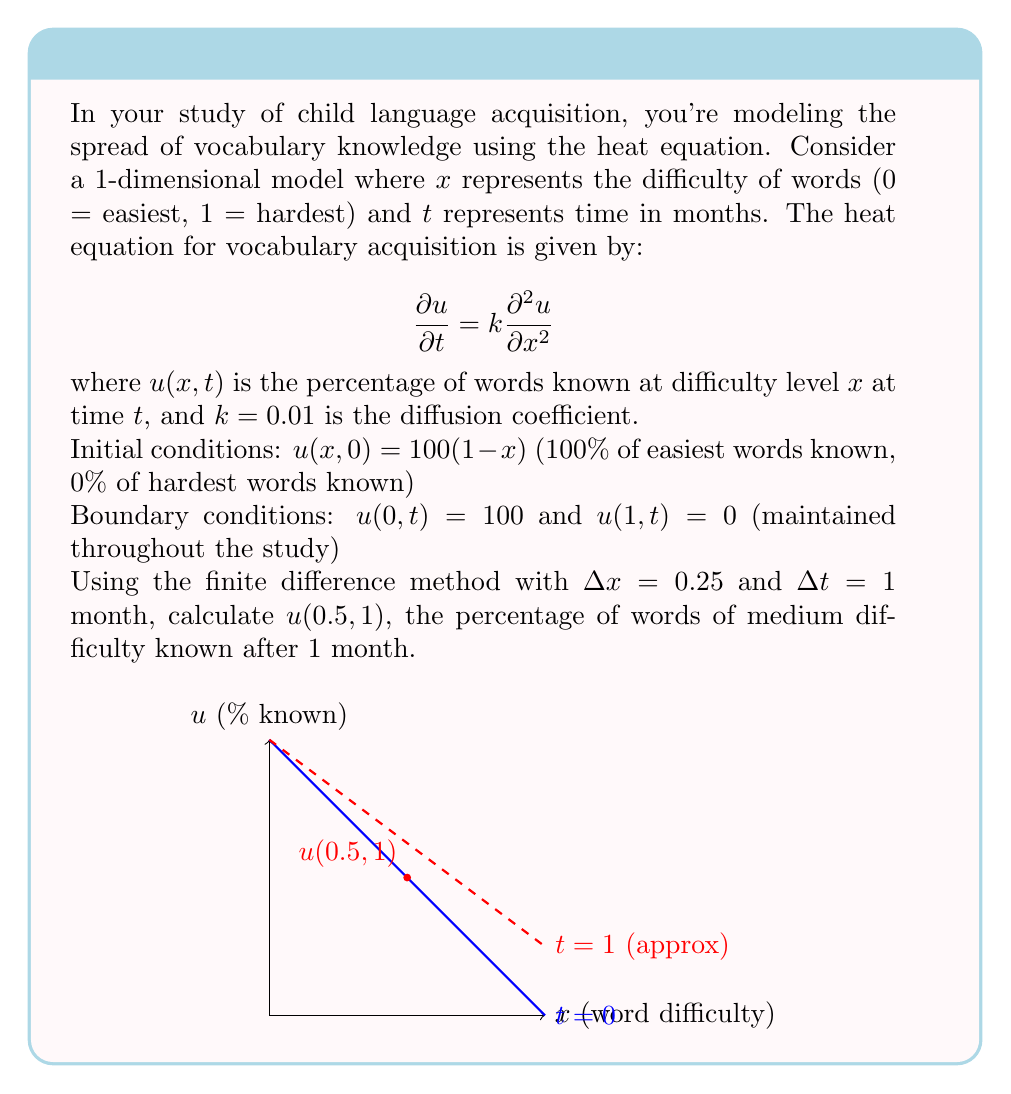Solve this math problem. Let's solve this step-by-step using the finite difference method:

1) The finite difference approximation for the heat equation is:

   $$\frac{u_i^{j+1} - u_i^j}{\Delta t} = k\frac{u_{i+1}^j - 2u_i^j + u_{i-1}^j}{(\Delta x)^2}$$

2) Rearranging to solve for $u_i^{j+1}$:

   $$u_i^{j+1} = u_i^j + \frac{k\Delta t}{(\Delta x)^2}(u_{i+1}^j - 2u_i^j + u_{i-1}^j)$$

3) Given: $k = 0.01$, $\Delta x = 0.25$, $\Delta t = 1$

4) Calculate the coefficient: $\frac{k\Delta t}{(\Delta x)^2} = \frac{0.01 \cdot 1}{0.25^2} = 0.16$

5) The grid points are:
   $x_0 = 0$, $x_1 = 0.25$, $x_2 = 0.5$, $x_3 = 0.75$, $x_4 = 1$

6) Initial conditions: $u_i^0 = 100(1-x_i)$
   $u_0^0 = 100$, $u_1^0 = 75$, $u_2^0 = 50$, $u_3^0 = 25$, $u_4^0 = 0$

7) Boundary conditions: $u_0^1 = 100$, $u_4^1 = 0$

8) For $u_2^1$ (which is $u(0.5, 1)$), we use the finite difference equation:

   $$u_2^1 = u_2^0 + 0.16(u_3^0 - 2u_2^0 + u_1^0)$$
   $$u_2^1 = 50 + 0.16(25 - 2(50) + 75)$$
   $$u_2^1 = 50 + 0.16(0) = 50$$

Therefore, $u(0.5, 1) = 50$.
Answer: 50% 